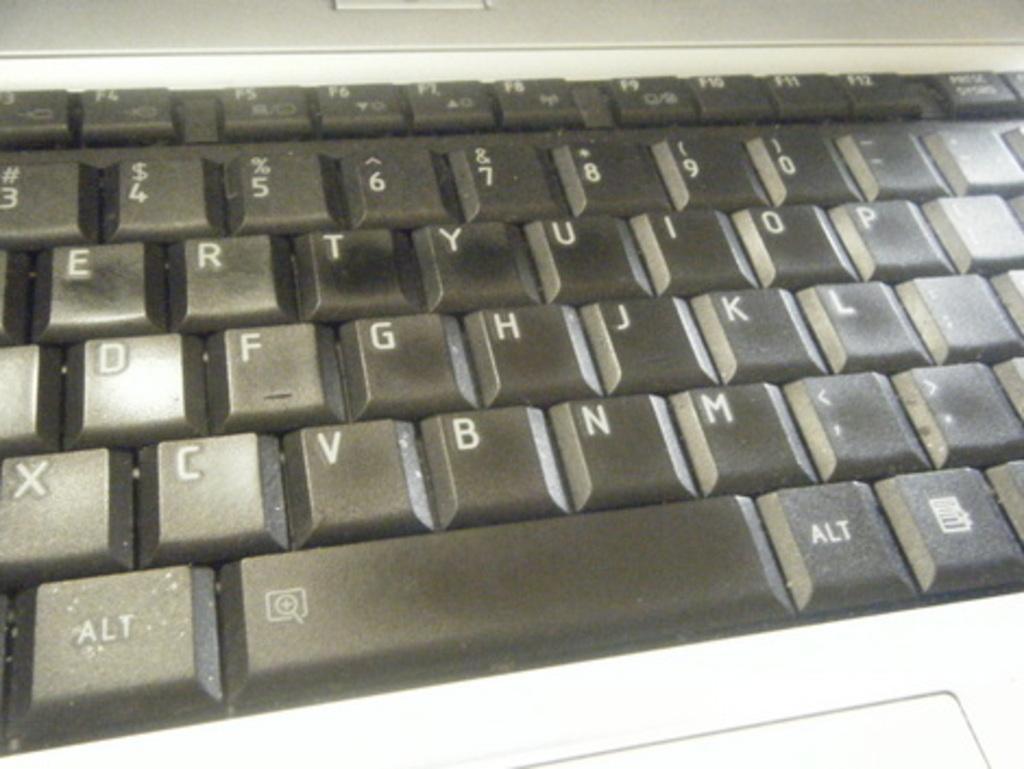What is the letter beneath y?
Your answer should be compact. H. What key is below m?
Your response must be concise. Alt. 